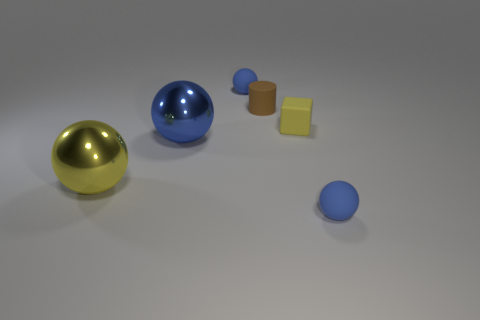What can you infer about the light source in this image based on the shadows? The shadows in the image are soft and appear to come from a light source located above and to the right of the objects. The angles and lengths of the shadows suggest that the light is diffused, perhaps indicating an overcast sky or a soft box light commonly used in photography studios. The way the light is reflected on the spheres and the silver cylinder also hints at a single, broad light source. 